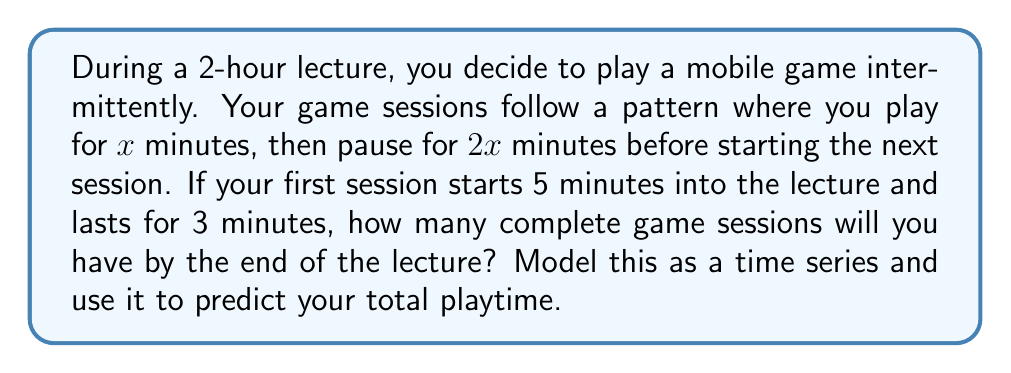Can you solve this math problem? Let's approach this step-by-step:

1) First, let's define our time series. Each element in the series will represent the duration of a game session, followed by a pause.

2) We're told that the first session lasts 3 minutes. So $x = 3$ for the first session.

3) The pattern is: play for $x$ minutes, pause for $2x$ minutes. So each cycle takes $3x$ minutes.

4) Let's model the series:
   Session 1: 3 minutes play + 6 minutes pause = 9 minutes
   Session 2: 3 minutes play + 6 minutes pause = 9 minutes
   Session 3: 3 minutes play + 6 minutes pause = 9 minutes
   ...and so on

5) Now, let's calculate how many complete cycles we can fit in the lecture:
   - The lecture is 120 minutes long
   - The first session starts 5 minutes in, so we have 115 minutes left
   - Each cycle takes 9 minutes

6) To find the number of complete cycles, we divide:
   $$\text{Number of cycles} = \left\lfloor\frac{115}{9}\right\rfloor = 12$$
   (We use the floor function because we only want complete cycles)

7) However, we need to check if there's enough time for the final play session:
   12 cycles * 9 minutes/cycle = 108 minutes
   115 - 108 = 7 minutes left, which is enough for the final 3-minute play session

8) Therefore, we have 13 complete play sessions.

9) To calculate total playtime:
   13 sessions * 3 minutes/session = 39 minutes total playtime
Answer: 13 complete game sessions, with a total playtime of 39 minutes. 